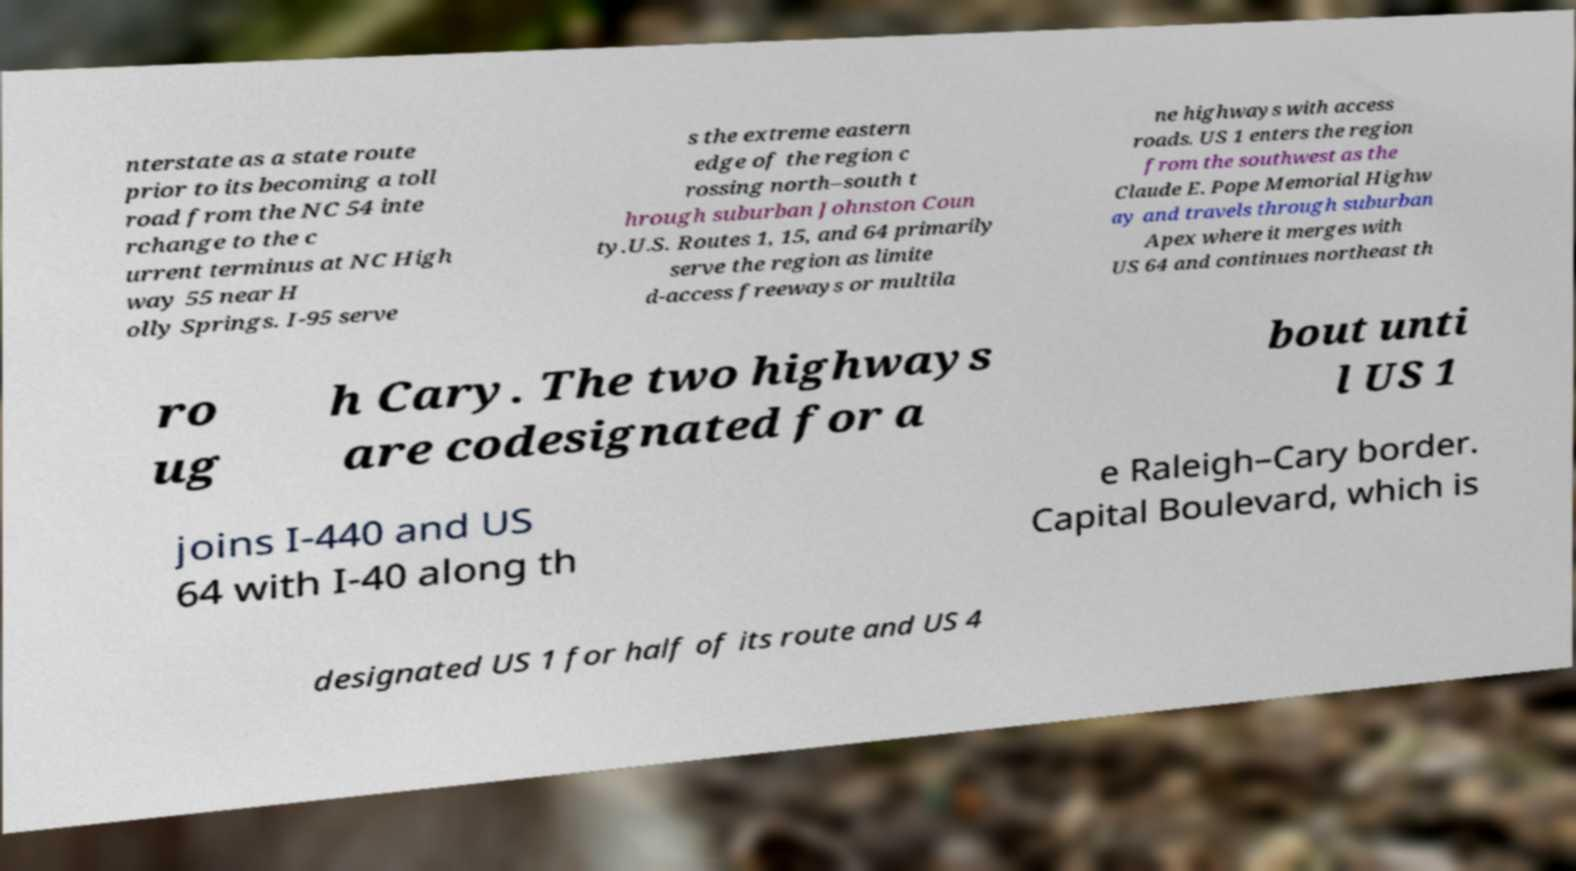Can you read and provide the text displayed in the image?This photo seems to have some interesting text. Can you extract and type it out for me? nterstate as a state route prior to its becoming a toll road from the NC 54 inte rchange to the c urrent terminus at NC High way 55 near H olly Springs. I-95 serve s the extreme eastern edge of the region c rossing north–south t hrough suburban Johnston Coun ty.U.S. Routes 1, 15, and 64 primarily serve the region as limite d-access freeways or multila ne highways with access roads. US 1 enters the region from the southwest as the Claude E. Pope Memorial Highw ay and travels through suburban Apex where it merges with US 64 and continues northeast th ro ug h Cary. The two highways are codesignated for a bout unti l US 1 joins I-440 and US 64 with I-40 along th e Raleigh–Cary border. Capital Boulevard, which is designated US 1 for half of its route and US 4 